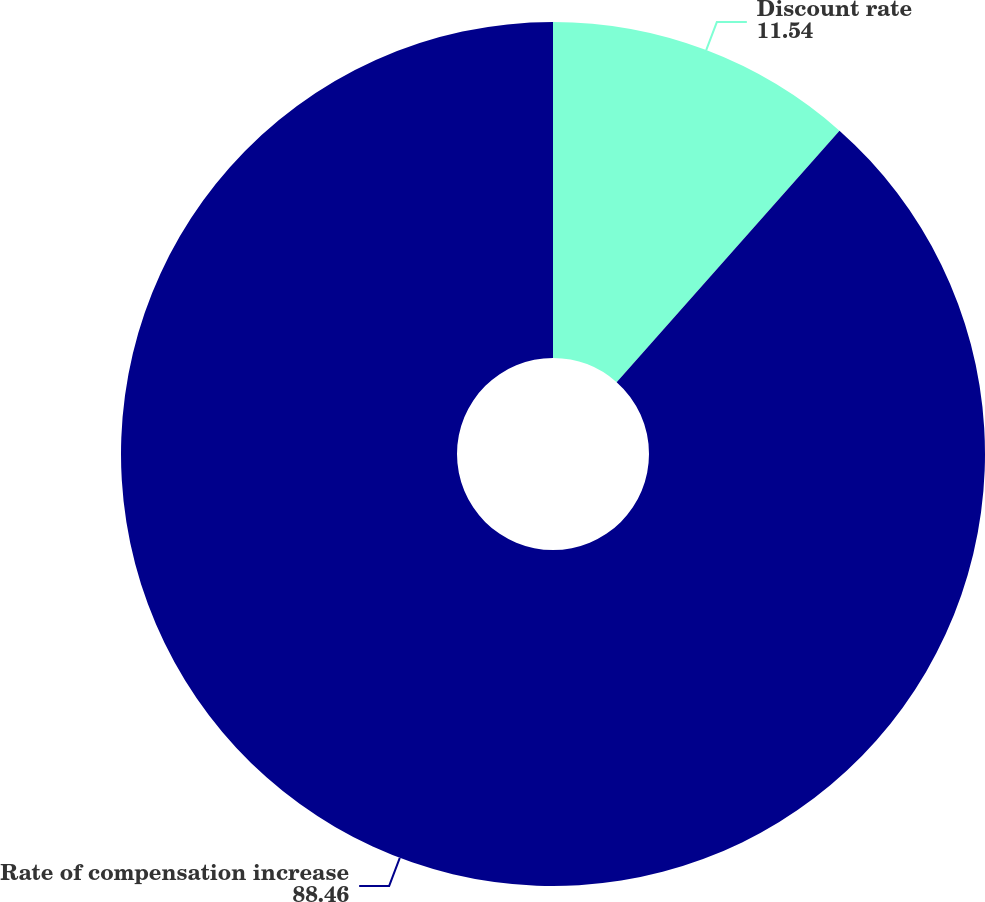Convert chart. <chart><loc_0><loc_0><loc_500><loc_500><pie_chart><fcel>Discount rate<fcel>Rate of compensation increase<nl><fcel>11.54%<fcel>88.46%<nl></chart> 